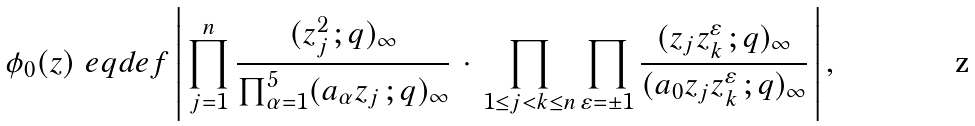<formula> <loc_0><loc_0><loc_500><loc_500>\phi _ { 0 } ( z ) \ e q d e f \left | \, \prod _ { j = 1 } ^ { n } \frac { ( z _ { j } ^ { 2 } \, ; q ) _ { \infty } } { \prod _ { \alpha = 1 } ^ { 5 } ( a _ { \alpha } z _ { j } \, ; q ) _ { \infty } } \, \cdot \, \prod _ { 1 \leq j < k \leq n } \prod _ { \varepsilon = \pm 1 } \frac { ( z _ { j } z _ { k } ^ { \varepsilon } \, ; q ) _ { \infty } } { ( a _ { 0 } z _ { j } z _ { k } ^ { \varepsilon } \, ; q ) _ { \infty } } \, \right | ,</formula> 